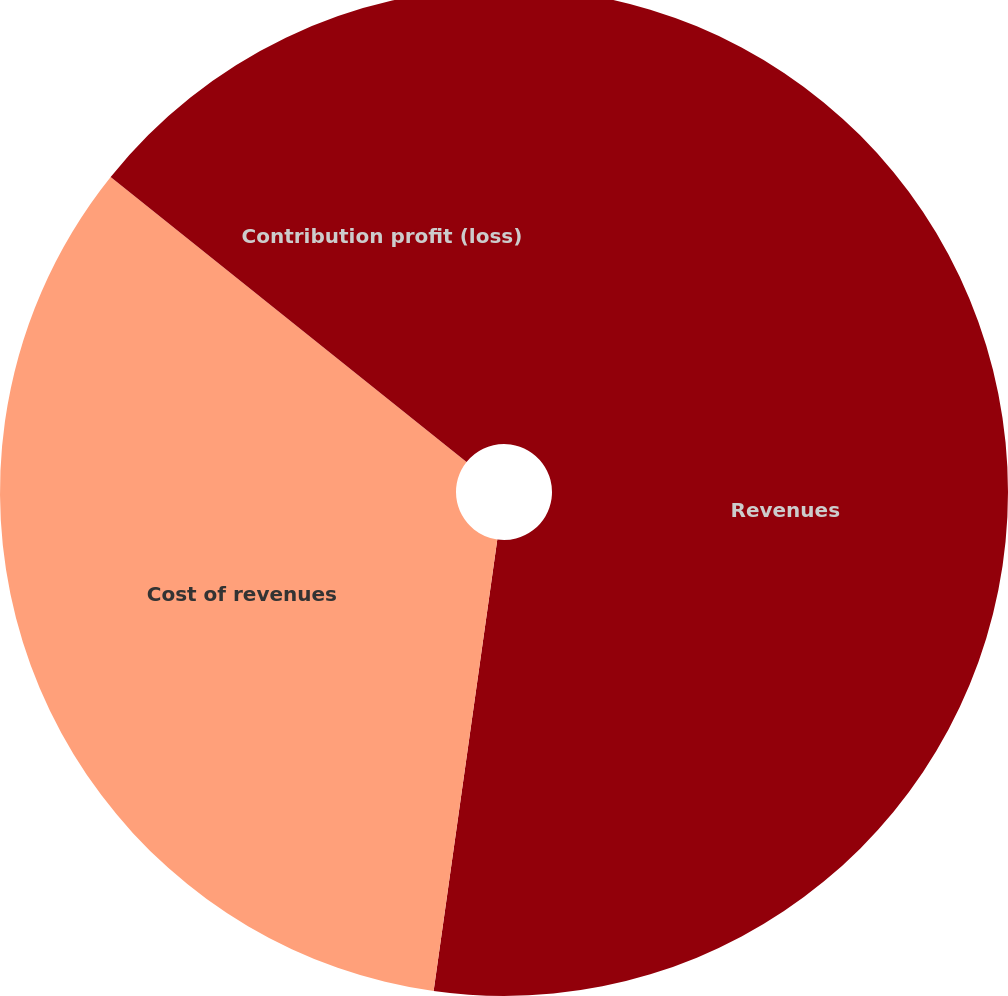Convert chart to OTSL. <chart><loc_0><loc_0><loc_500><loc_500><pie_chart><fcel>Revenues<fcel>Cost of revenues<fcel>Contribution profit (loss)<nl><fcel>52.23%<fcel>33.52%<fcel>14.25%<nl></chart> 